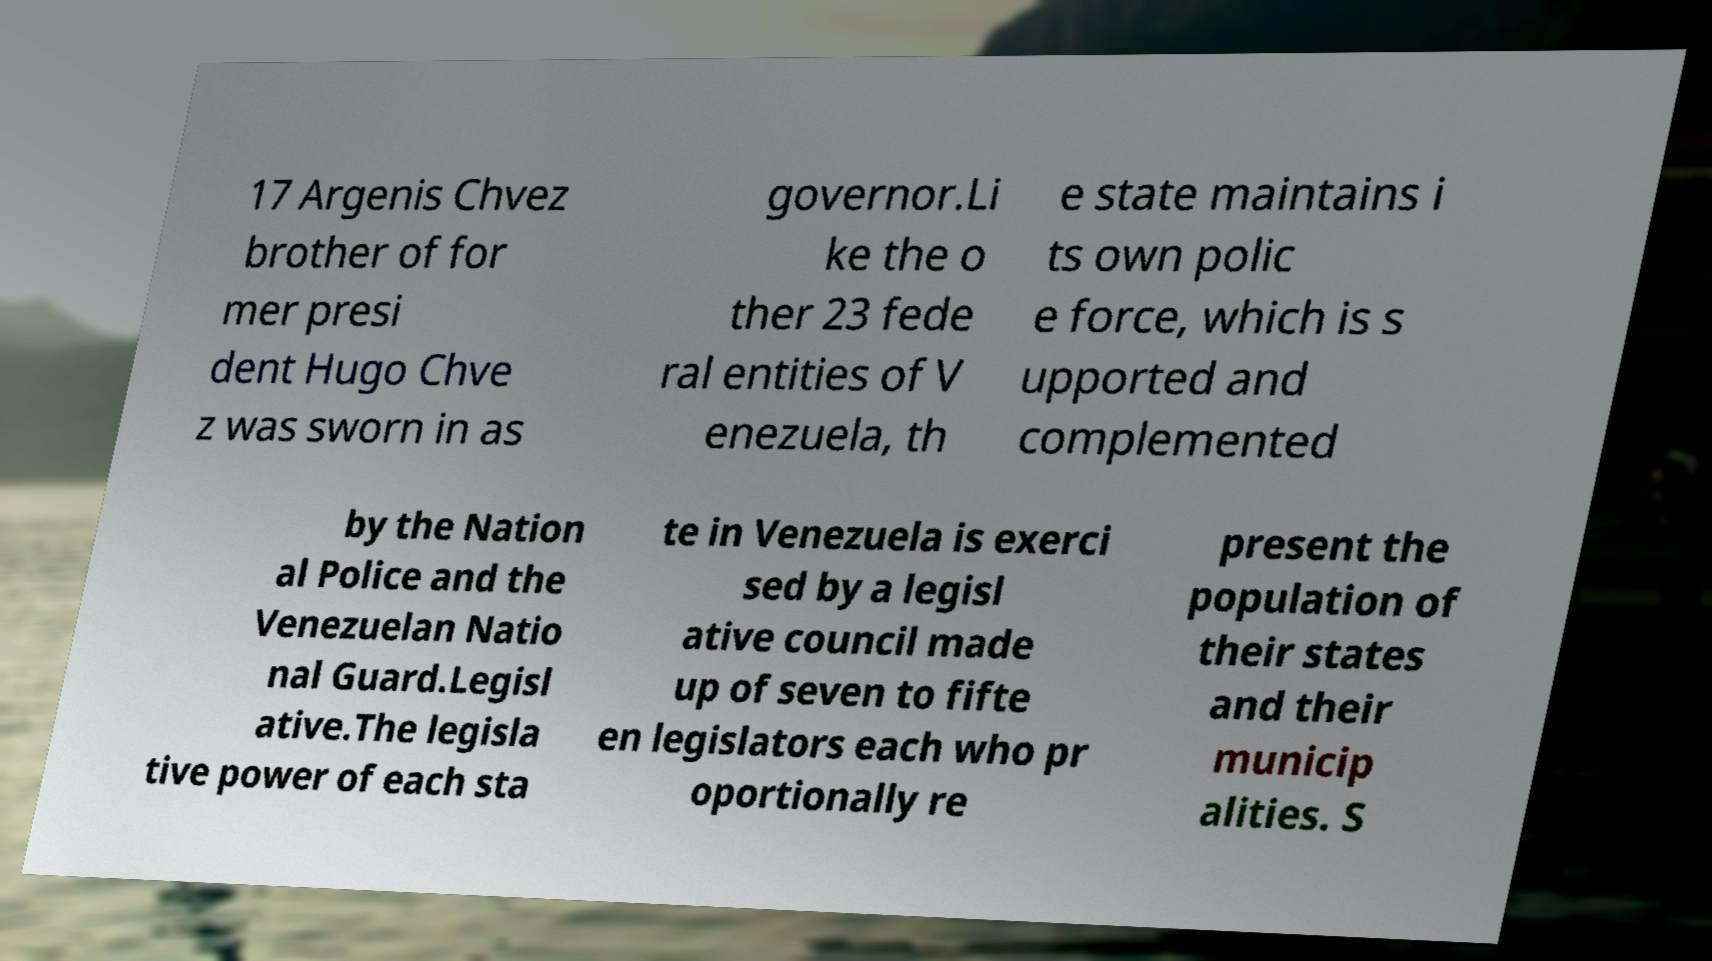What messages or text are displayed in this image? I need them in a readable, typed format. 17 Argenis Chvez brother of for mer presi dent Hugo Chve z was sworn in as governor.Li ke the o ther 23 fede ral entities of V enezuela, th e state maintains i ts own polic e force, which is s upported and complemented by the Nation al Police and the Venezuelan Natio nal Guard.Legisl ative.The legisla tive power of each sta te in Venezuela is exerci sed by a legisl ative council made up of seven to fifte en legislators each who pr oportionally re present the population of their states and their municip alities. S 